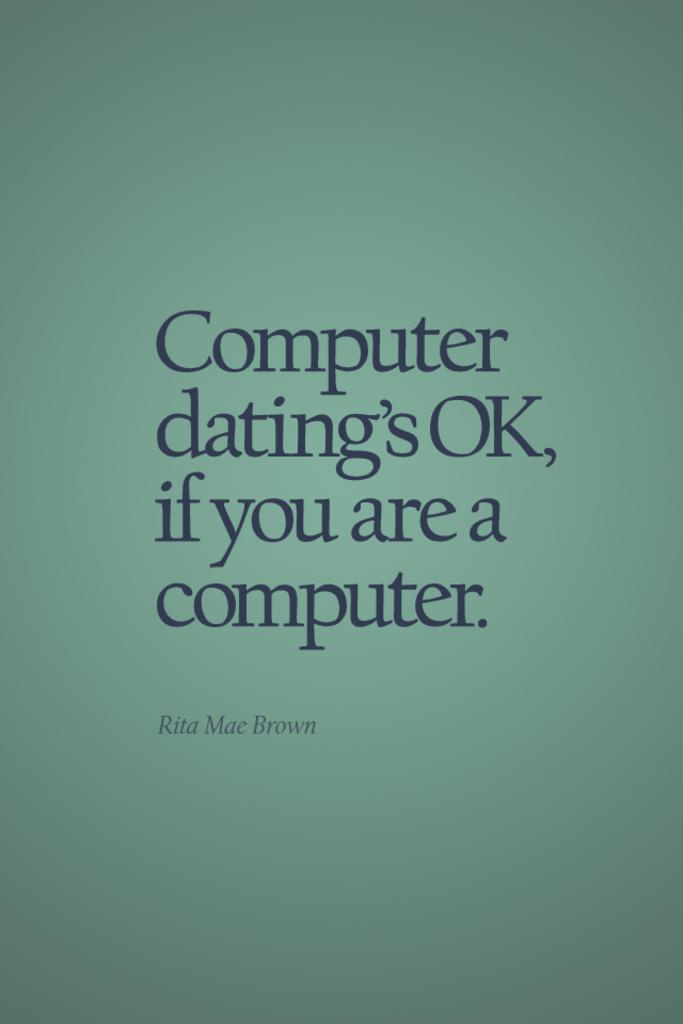<image>
Relay a brief, clear account of the picture shown. The cover image of Rita Mae Brown's Computer Dating publication 